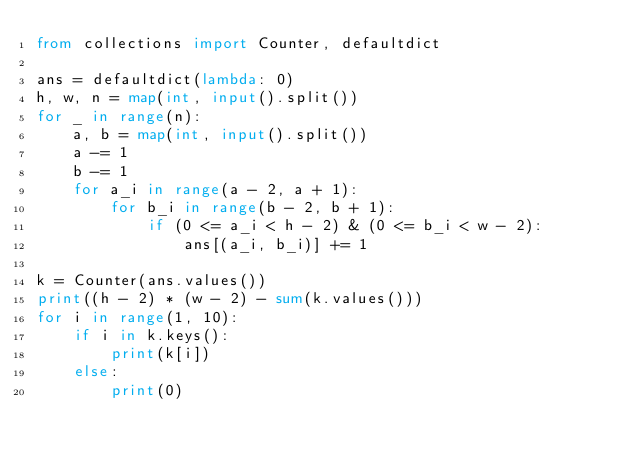<code> <loc_0><loc_0><loc_500><loc_500><_Python_>from collections import Counter, defaultdict

ans = defaultdict(lambda: 0)
h, w, n = map(int, input().split())
for _ in range(n):
    a, b = map(int, input().split())
    a -= 1
    b -= 1
    for a_i in range(a - 2, a + 1):
        for b_i in range(b - 2, b + 1):
            if (0 <= a_i < h - 2) & (0 <= b_i < w - 2):
                ans[(a_i, b_i)] += 1

k = Counter(ans.values())
print((h - 2) * (w - 2) - sum(k.values()))
for i in range(1, 10):
    if i in k.keys():
        print(k[i])
    else:
        print(0)</code> 